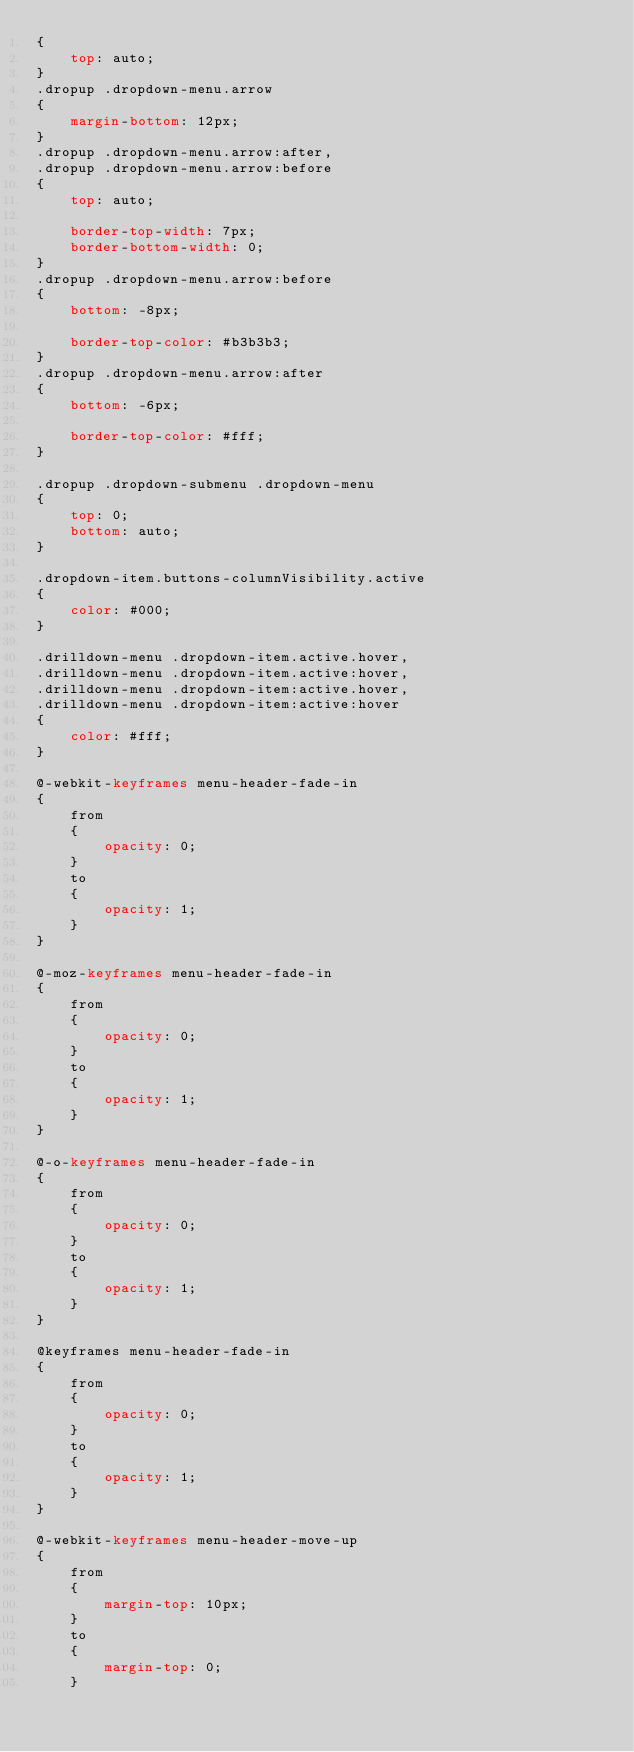<code> <loc_0><loc_0><loc_500><loc_500><_CSS_>{
    top: auto;
}
.dropup .dropdown-menu.arrow
{
    margin-bottom: 12px;
}
.dropup .dropdown-menu.arrow:after,
.dropup .dropdown-menu.arrow:before
{
    top: auto;

    border-top-width: 7px;
    border-bottom-width: 0;
}
.dropup .dropdown-menu.arrow:before
{
    bottom: -8px;

    border-top-color: #b3b3b3;
}
.dropup .dropdown-menu.arrow:after
{
    bottom: -6px;

    border-top-color: #fff;
}

.dropup .dropdown-submenu .dropdown-menu
{
    top: 0; 
    bottom: auto;
}

.dropdown-item.buttons-columnVisibility.active
{
    color: #000;
}

.drilldown-menu .dropdown-item.active.hover,
.drilldown-menu .dropdown-item.active:hover,
.drilldown-menu .dropdown-item:active.hover,
.drilldown-menu .dropdown-item:active:hover
{
    color: #fff;
}

@-webkit-keyframes menu-header-fade-in
{
    from
    {
        opacity: 0;
    }
    to
    {
        opacity: 1;
    }
}

@-moz-keyframes menu-header-fade-in
{
    from
    {
        opacity: 0;
    }
    to
    {
        opacity: 1;
    }
}

@-o-keyframes menu-header-fade-in
{
    from
    {
        opacity: 0;
    }
    to
    {
        opacity: 1;
    }
}

@keyframes menu-header-fade-in
{
    from
    {
        opacity: 0;
    }
    to
    {
        opacity: 1;
    }
}

@-webkit-keyframes menu-header-move-up
{
    from
    {
        margin-top: 10px;
    }
    to
    {
        margin-top: 0;
    }</code> 